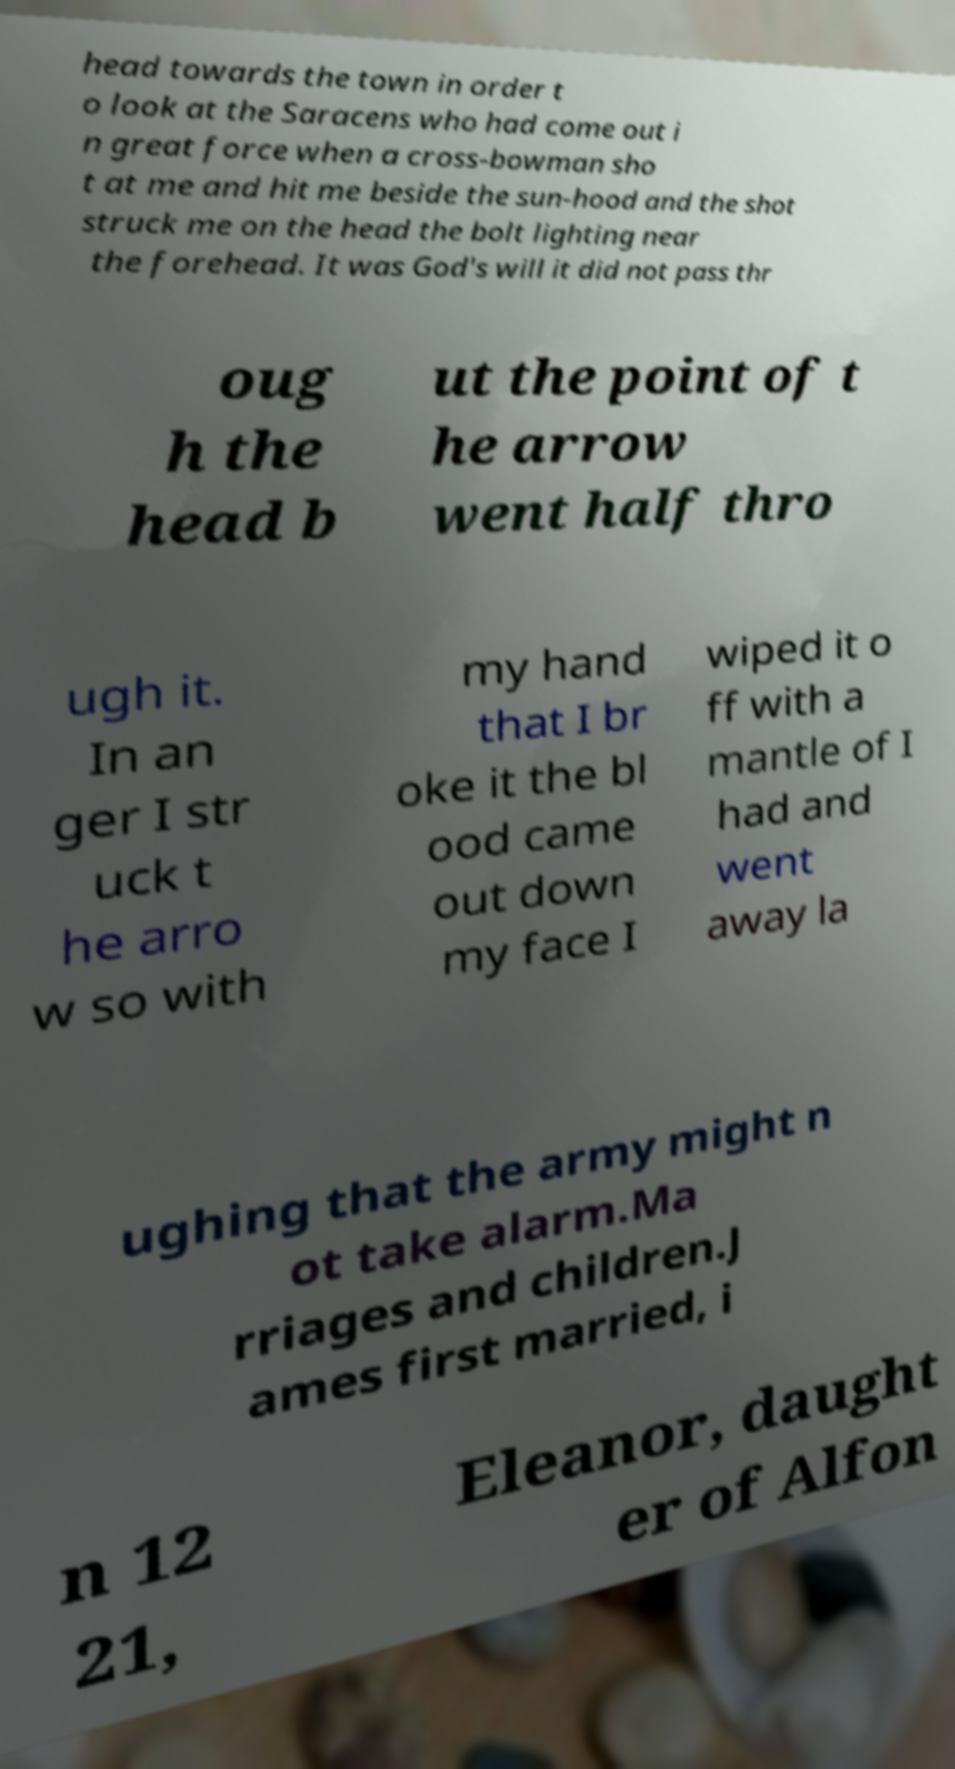For documentation purposes, I need the text within this image transcribed. Could you provide that? head towards the town in order t o look at the Saracens who had come out i n great force when a cross-bowman sho t at me and hit me beside the sun-hood and the shot struck me on the head the bolt lighting near the forehead. It was God's will it did not pass thr oug h the head b ut the point of t he arrow went half thro ugh it. In an ger I str uck t he arro w so with my hand that I br oke it the bl ood came out down my face I wiped it o ff with a mantle of I had and went away la ughing that the army might n ot take alarm.Ma rriages and children.J ames first married, i n 12 21, Eleanor, daught er of Alfon 